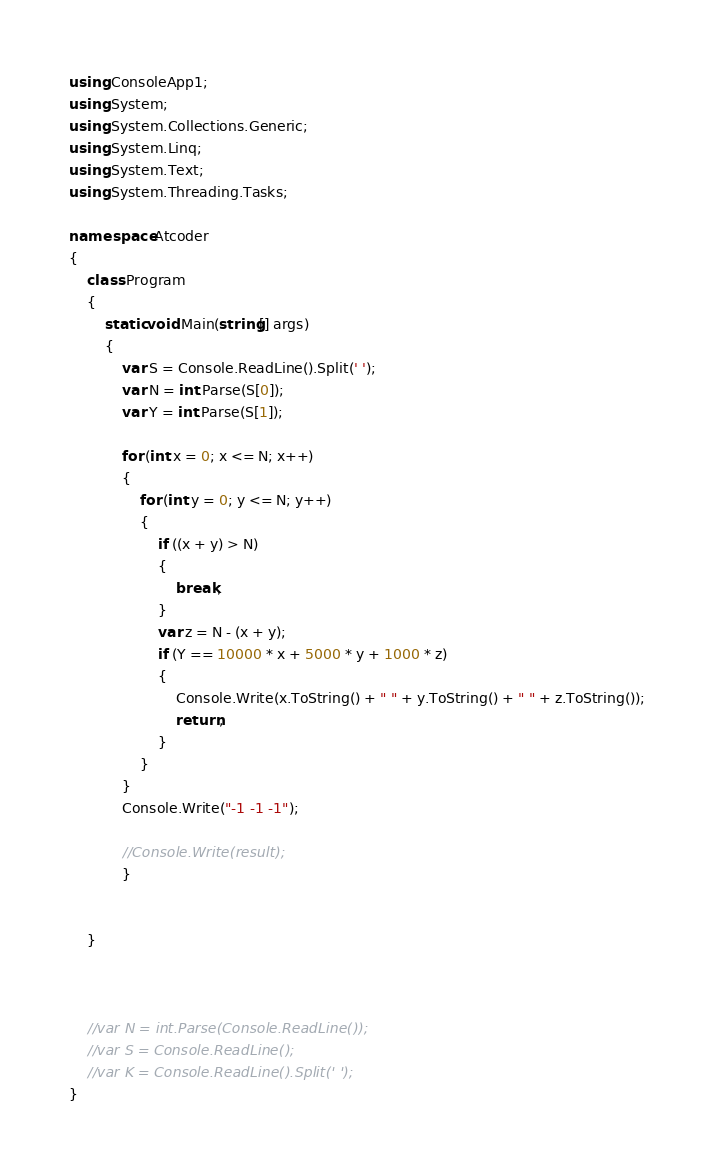<code> <loc_0><loc_0><loc_500><loc_500><_C#_>using ConsoleApp1;
using System;
using System.Collections.Generic;
using System.Linq;
using System.Text;
using System.Threading.Tasks;

namespace Atcoder
{
    class Program
    {
        static void Main(string[] args)
        {
            var S = Console.ReadLine().Split(' ');
            var N = int.Parse(S[0]);
            var Y = int.Parse(S[1]);

            for (int x = 0; x <= N; x++)
            {
                for (int y = 0; y <= N; y++)
                {
                    if ((x + y) > N)
                    {
                        break;
                    }
                    var z = N - (x + y);
                    if (Y == 10000 * x + 5000 * y + 1000 * z)
                    {
                        Console.Write(x.ToString() + " " + y.ToString() + " " + z.ToString());
                        return;
                    }
                }
            }
            Console.Write("-1 -1 -1");

            //Console.Write(result);
            }


    }



    //var N = int.Parse(Console.ReadLine());
    //var S = Console.ReadLine();
    //var K = Console.ReadLine().Split(' ');
}
</code> 